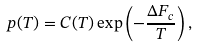Convert formula to latex. <formula><loc_0><loc_0><loc_500><loc_500>p ( T ) = C ( T ) \exp \left ( - \frac { \Delta F _ { c } } { T } \right ) ,</formula> 